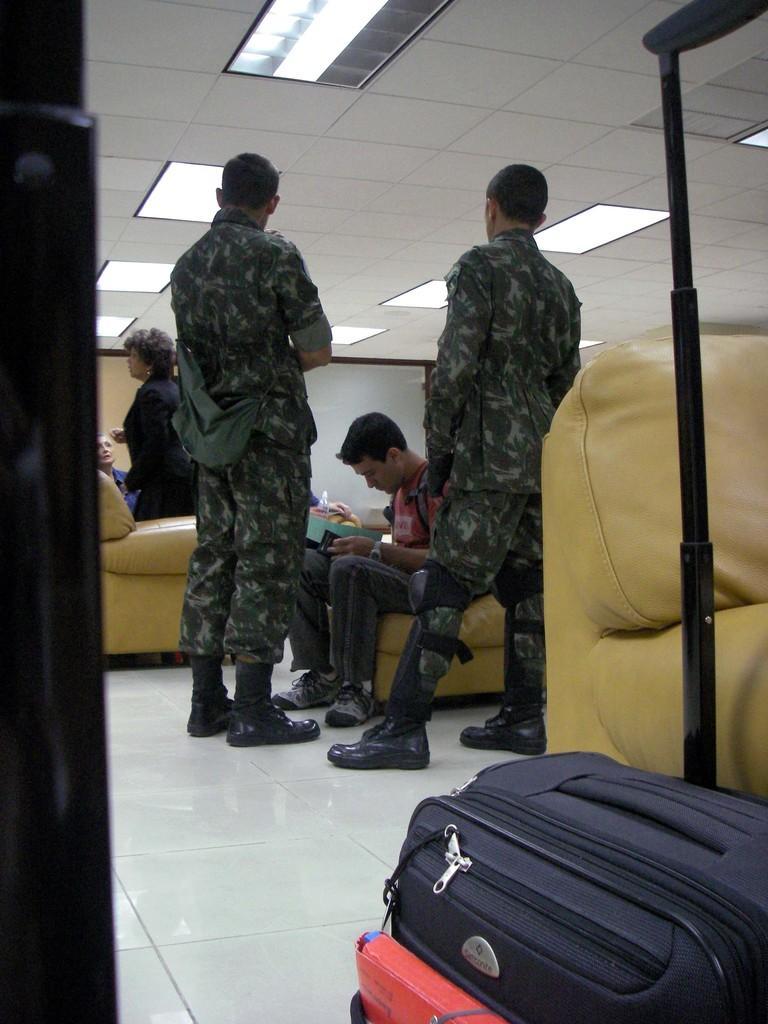How would you summarize this image in a sentence or two? These two persons are standing and wore military dress. This person is sitting on a couch and hold a file. Beside this couch there is a luggage. On top there are lights. For this woman is standing and wore black dress. 